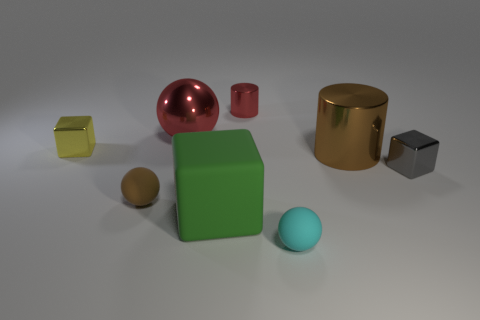Subtract all small spheres. How many spheres are left? 1 Add 1 small cyan matte things. How many objects exist? 9 Subtract all brown cylinders. How many cylinders are left? 1 Subtract all cylinders. How many objects are left? 6 Subtract 0 brown cubes. How many objects are left? 8 Subtract 2 cubes. How many cubes are left? 1 Subtract all brown blocks. Subtract all gray spheres. How many blocks are left? 3 Subtract all large cylinders. Subtract all rubber things. How many objects are left? 4 Add 5 metal things. How many metal things are left? 10 Add 7 metal cylinders. How many metal cylinders exist? 9 